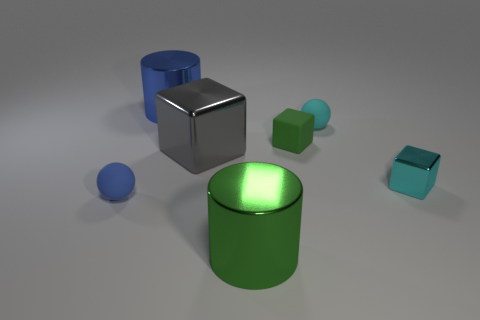What can you tell me about the different shapes presented here? The image showcases a variety of geometric shapes, including cylinders, cubes, and spheres. The assortment of shapes may be intended to illustrate geometric diversity or could be used in a pedagogical context to teach about three-dimensional forms. 